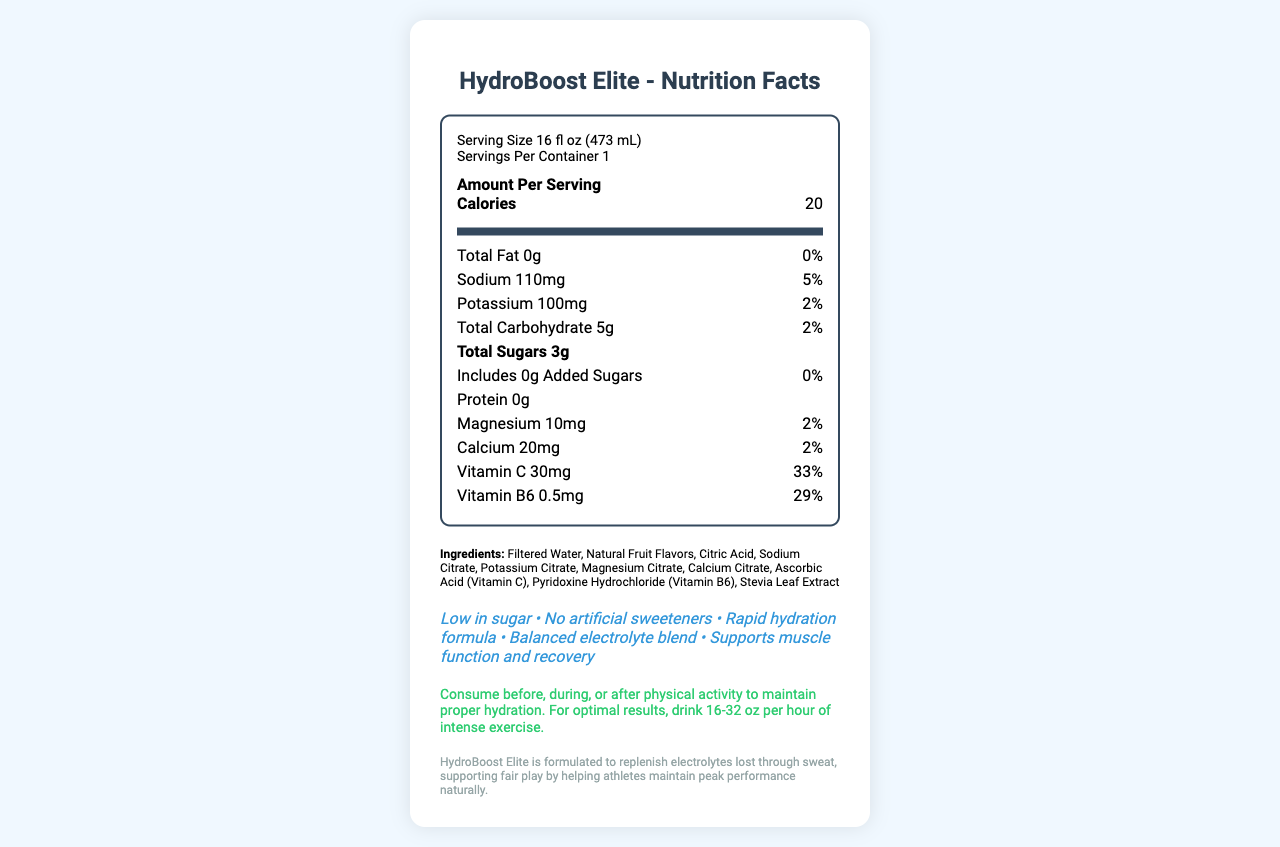what is the name of the product? The name of the product is displayed as the title of the document.
Answer: HydroBoost Elite what is the serving size? The serving size is listed in the serving info section.
Answer: 16 fl oz (473 mL) how many servings per container? The servings per container are mentioned in the serving info section.
Answer: 1 how much sodium does each serving contain? The sodium content per serving is provided in the nutrition label.
Answer: 110mg which vitamins are included in this product? The vitamins included are listed in the nutrient item section as Vitamin C 30mg and Vitamin B6 0.5mg.
Answer: Vitamin C and Vitamin B6 how many calories are in one serving? A. 10 B. 20 C. 30 The calorie count per serving is provided immediately under "Amount Per Serving."
Answer: B what percentage of daily value for vitamin C does this product provide? A. 20% B. 29% C. 33% The daily value percentage for Vitamin C is listed as 33% in the nutrient item section.
Answer: C in which facility is this product produced? A. Dairy B. Soy and tree nuts C. Wheat and gluten The allergen information indicates that the product is produced in a facility that processes soy and tree nuts.
Answer: B is the product low in sugar? The marketing claims mention "Low in sugar" as one of the key features.
Answer: Yes does this product contain artificial sweeteners? The marketing claims clearly state "No artificial sweeteners."
Answer: No summarize the main features of the HydroBoost Elite. The summary is derived from various sections including marketing claims, nutrient content, and usage instructions.
Answer: HydroBoost Elite is a sports drink that offers a rapid hydration formula with balanced electrolytes, low sugar content, no artificial sweeteners, and vitamins like Vitamin C and B6. It's designed to support muscle function and recovery, and is recommended to be consumed before, during, or after physical activity. what is the recommended consumption rate for optimal results? The specific recommended consumption rate (16-32 oz per hour of intense exercise) is mentioned in the usage instructions, but the exact optimal rate based on individual needs cannot be determined from the document alone.
Answer: Cannot be determined how many grams of protein are in one serving? The protein content per serving is clearly listed as 0g in the nutrient item section.
Answer: 0g what ingredients contribute to the electrolyte content? The ingredients list includes these compounds, which are typical sources of electrolytes.
Answer: Sodium Citrate, Potassium Citrate, Magnesium Citrate, Calcium Citrate what is the main ingredient in HydroBoost Elite? The first ingredient listed is Filtered Water, which typically indicates it's the main ingredient.
Answer: Filtered Water 